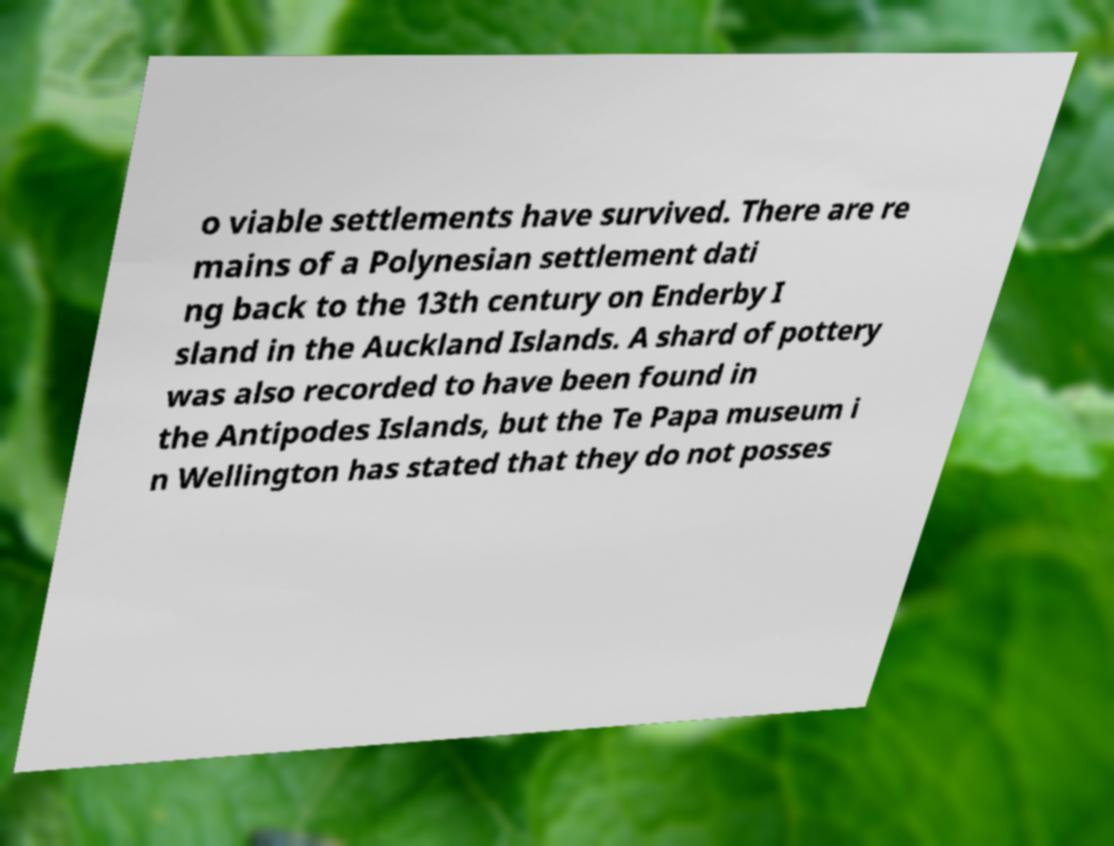I need the written content from this picture converted into text. Can you do that? o viable settlements have survived. There are re mains of a Polynesian settlement dati ng back to the 13th century on Enderby I sland in the Auckland Islands. A shard of pottery was also recorded to have been found in the Antipodes Islands, but the Te Papa museum i n Wellington has stated that they do not posses 